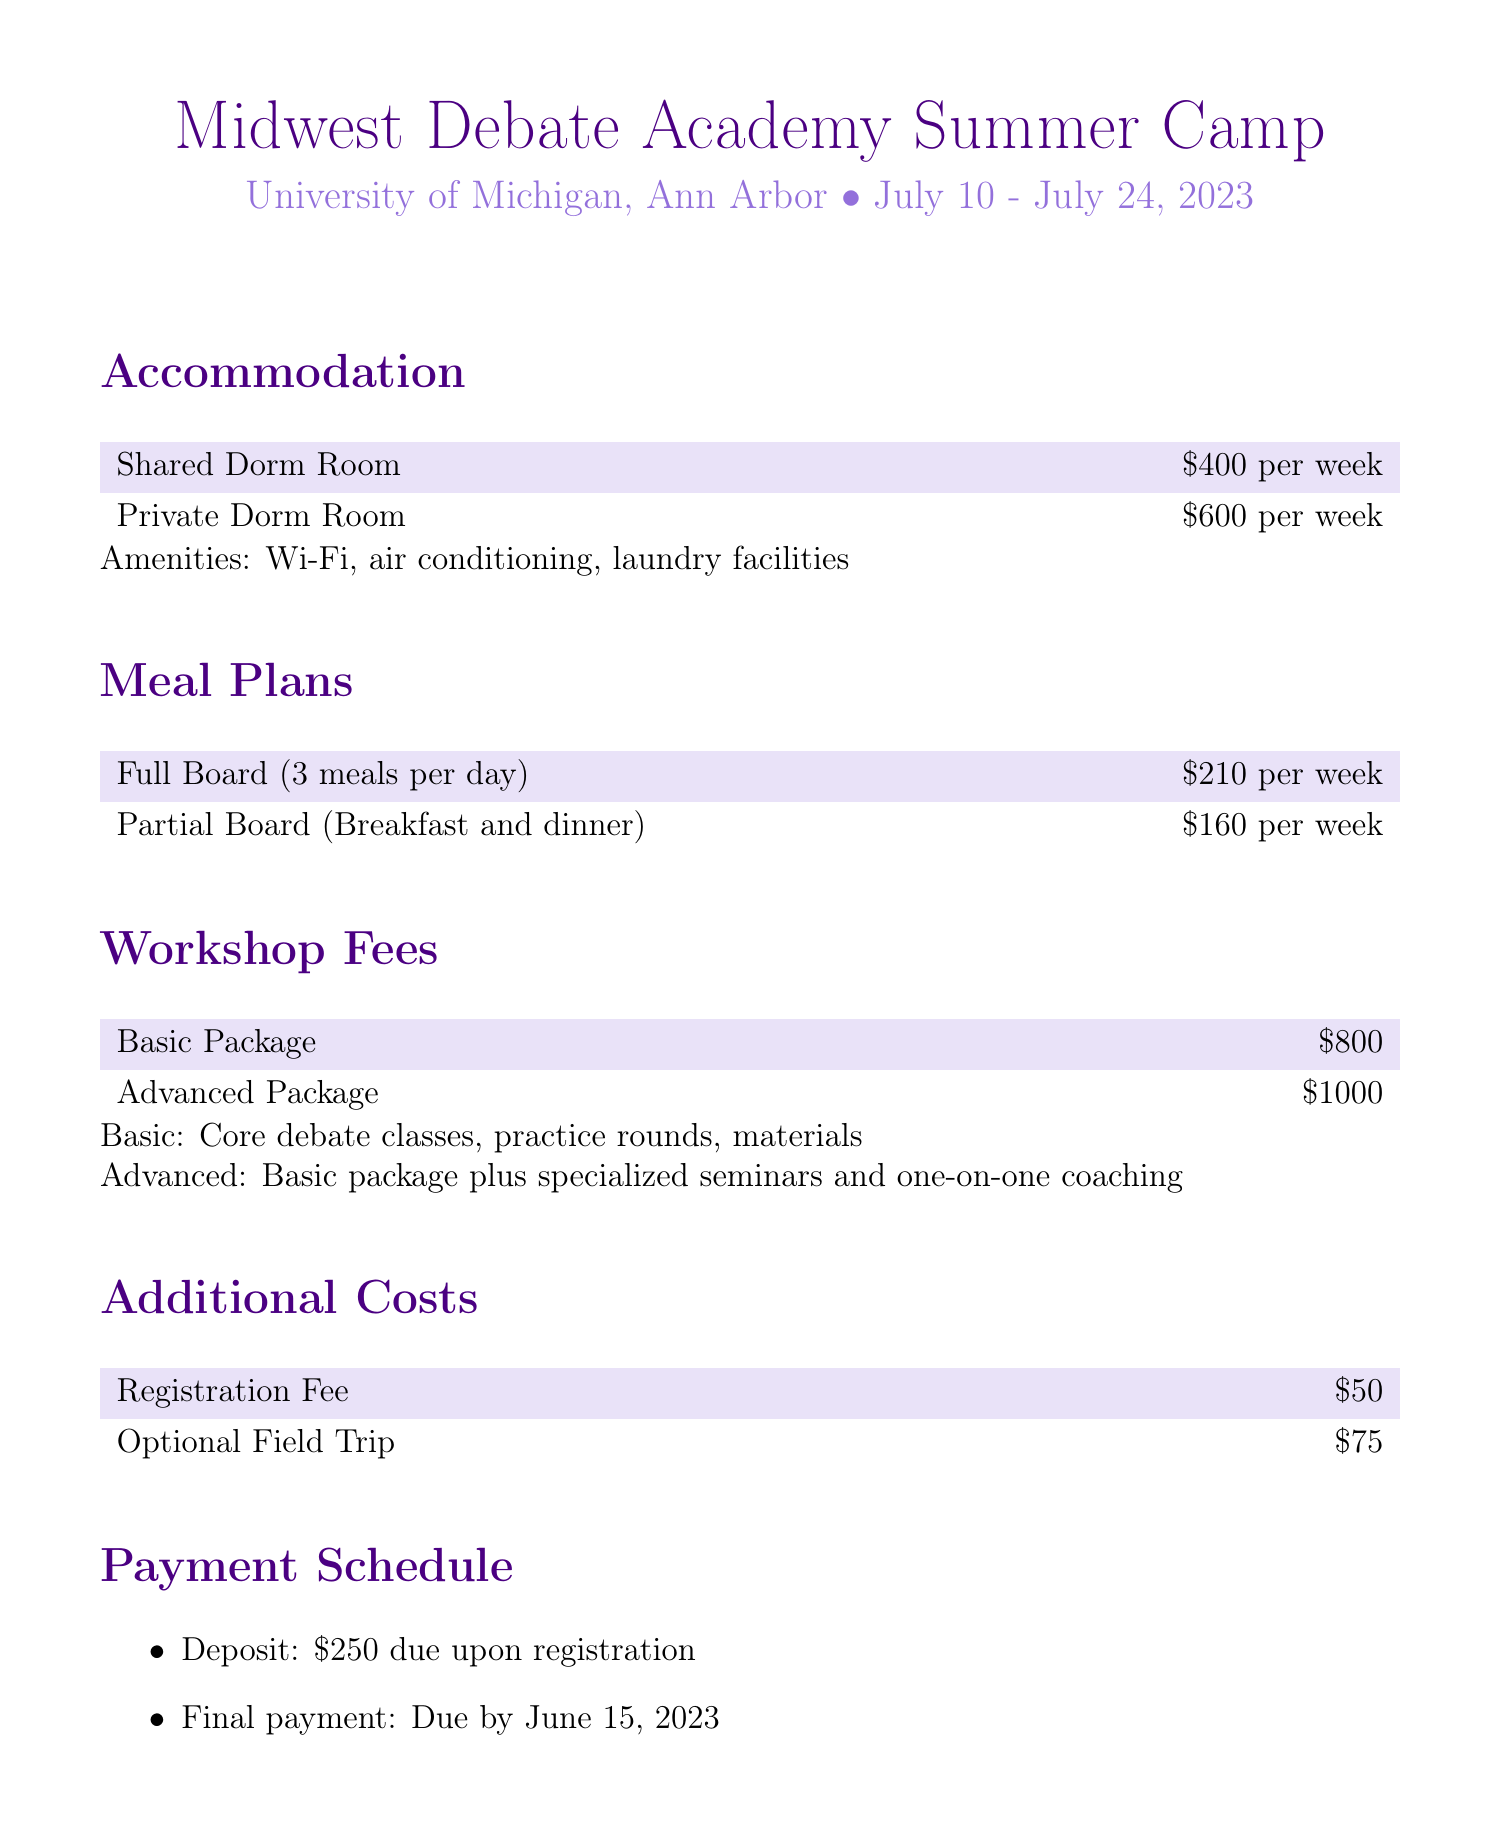What is the location of the camp? The camp is held at the University of Michigan, Ann Arbor.
Answer: University of Michigan, Ann Arbor What is the price for a private dorm room per week? The document states that a private dorm room costs $600 per week.
Answer: $600 per week What is the total cost for full board meal plan for two weeks? Full board costs $210 per week, so for two weeks it is $210 x 2 = $420.
Answer: $420 How many meals are included in the partial board meal plan? The partial board meal plan includes breakfast and dinner, which totals to two meals a day.
Answer: 2 meals What is the deposit amount due upon registration? The document specifies that the deposit amount due upon registration is $250.
Answer: $250 What is included in the advanced workshop package? The advanced package includes the basic package and specialized seminars and one-on-one coaching.
Answer: Specialized seminars and one-on-one coaching What is the registration fee for the camp? The registration fee mentioned is $50.
Answer: $50 What is the cancellation fee if cancelled after June 1, 2023? The cancellation policy states that there is a full refund minus a $100 processing fee if cancelled before June 1.
Answer: $100 processing fee When is the final payment due? The final payment is due by June 15, 2023, as stated in the document.
Answer: June 15, 2023 